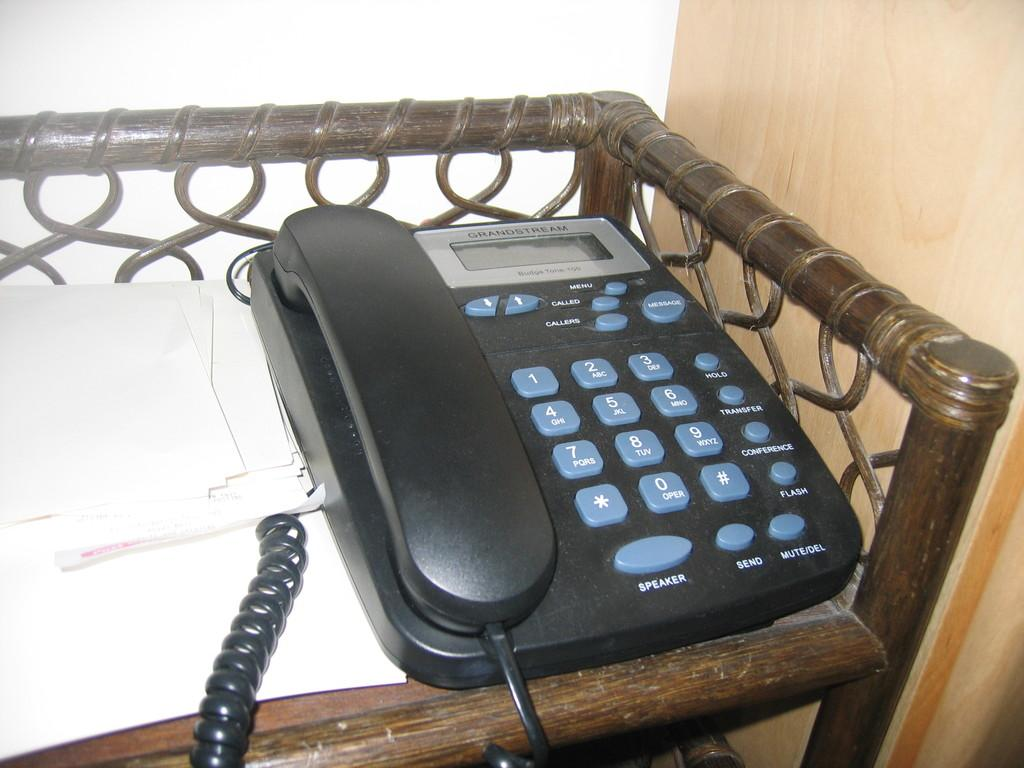What type of telephone is in the image? There is a black color telephone in the image. What is located near the telephone? There are white color papers beside the telephone. What can be seen on the right side of the image? There is a wooden wall on the right side of the image. What type of horn is attached to the telephone in the image? There is no horn attached to the telephone in the image. Is there a tank visible in the image? There is no tank present in the image. 